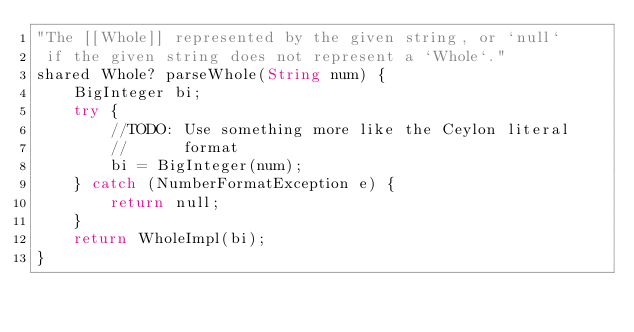Convert code to text. <code><loc_0><loc_0><loc_500><loc_500><_Ceylon_>"The [[Whole]] represented by the given string, or `null` 
 if the given string does not represent a `Whole`."
shared Whole? parseWhole(String num) {
    BigInteger bi;
    try {
        //TODO: Use something more like the Ceylon literal 
        //      format
        bi = BigInteger(num);
    } catch (NumberFormatException e) {
        return null;
    }
    return WholeImpl(bi);
}</code> 